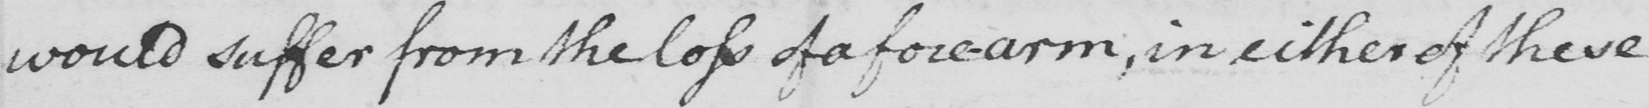Please provide the text content of this handwritten line. would suffer from the loss of a fore-arm, in either of these 